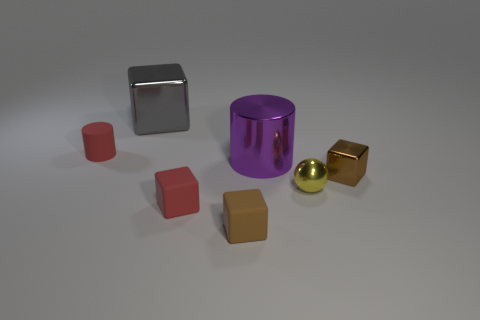There is a red object behind the big purple metallic thing to the right of the small thing that is to the left of the gray object; what is it made of?
Offer a very short reply. Rubber. Are there an equal number of small metal blocks in front of the tiny brown matte object and big gray matte cubes?
Make the answer very short. Yes. Is the tiny brown thing on the left side of the small yellow sphere made of the same material as the big object on the left side of the large metal cylinder?
Provide a short and direct response. No. How many things are either small yellow metallic things or cylinders behind the large purple thing?
Provide a short and direct response. 2. Are there any other things of the same shape as the tiny brown metallic thing?
Your response must be concise. Yes. There is a brown cube behind the red thing in front of the cylinder to the left of the large gray object; what is its size?
Ensure brevity in your answer.  Small. Is the number of gray cubes on the right side of the large gray cube the same as the number of brown blocks to the left of the red rubber block?
Your response must be concise. Yes. The gray object that is the same material as the yellow ball is what size?
Your response must be concise. Large. What color is the big metal cylinder?
Ensure brevity in your answer.  Purple. What number of objects have the same color as the small matte cylinder?
Keep it short and to the point. 1. 